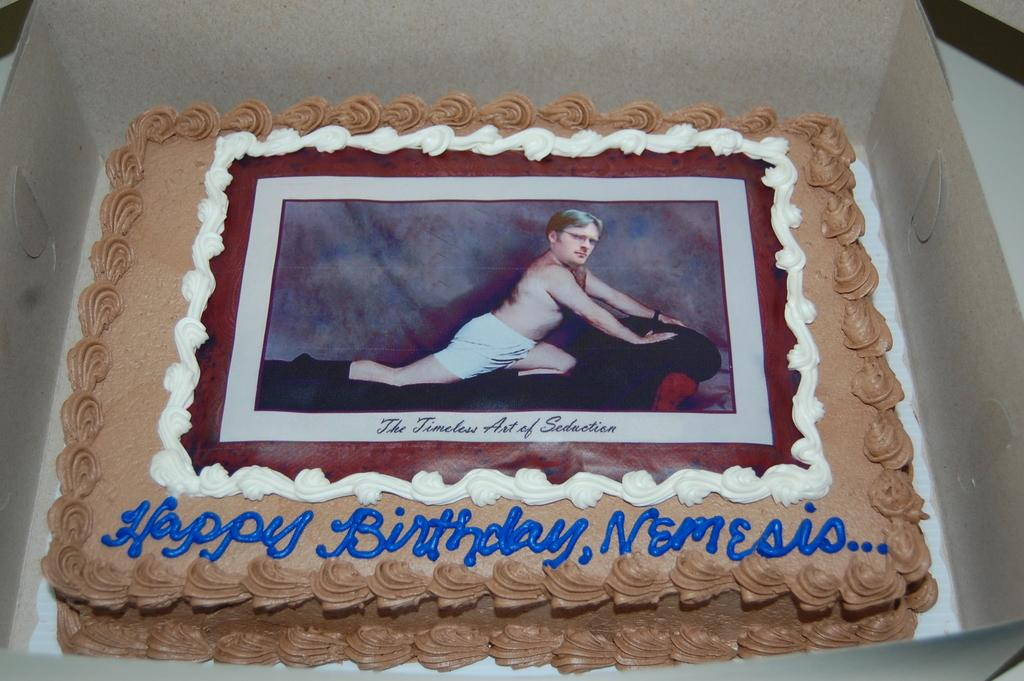What is the main subject of the image? The main subject of the image is a cake. How is the cake being stored or transported? The cake is in a box. What is depicted on the surface of the cake? There is an image of a man on the cake. Are there any words or phrases written on the cake? Yes, there is text on the cake. How many apples are visible on the cake in the image? There are no apples visible on the cake in the image. What type of toys can be seen playing with the airplane on the cake? There are no toys or airplanes present on the cake in the image. 